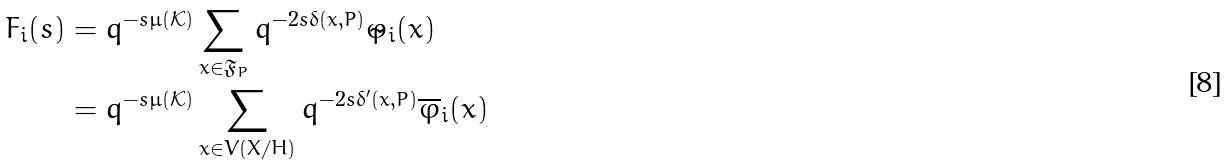<formula> <loc_0><loc_0><loc_500><loc_500>F _ { i } ( s ) & = q ^ { - s \mu ( \mathcal { K } ) } \sum _ { x \in \mathfrak { F } _ { P } } q ^ { - 2 s \delta ( x , P ) } \tilde { \varphi } _ { i } ( x ) \\ & = q ^ { - s \mu ( \mathcal { K } ) } \sum _ { x \in V ( X / H ) } q ^ { - 2 s \delta ^ { \prime } ( x , P ) } \overline { \varphi } _ { i } ( x )</formula> 